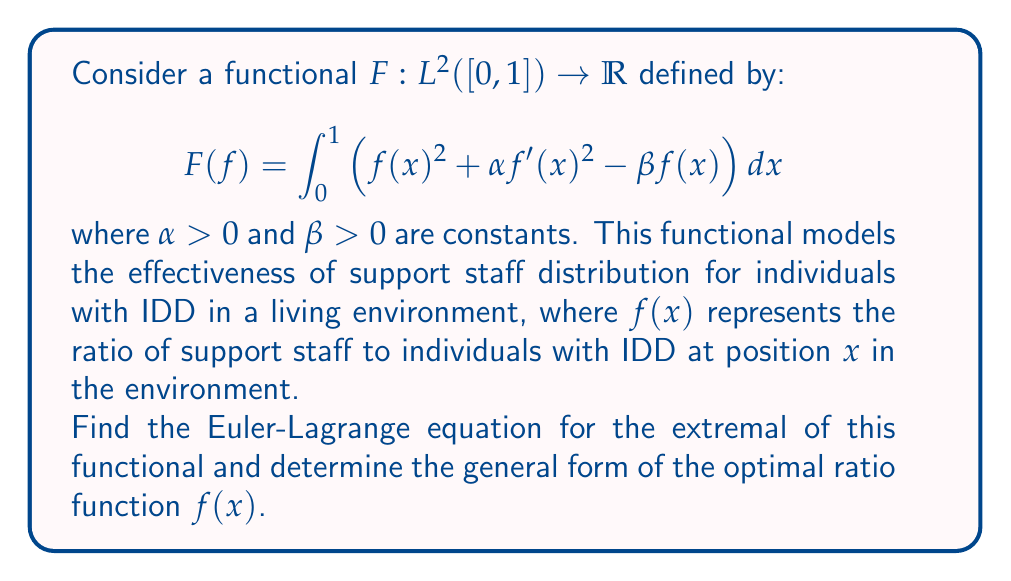Could you help me with this problem? To solve this problem, we'll use the Euler-Lagrange equation from the calculus of variations. The steps are as follows:

1) The Euler-Lagrange equation for a functional of the form $F(f) = \int_a^b L(x, f, f') dx$ is:

   $$\frac{\partial L}{\partial f} - \frac{d}{dx}\left(\frac{\partial L}{\partial f'}\right) = 0$$

2) In our case, $L(x, f, f') = f^2 + \alpha (f')^2 - \beta f$

3) Calculate the partial derivatives:
   
   $\frac{\partial L}{\partial f} = 2f - \beta$
   
   $\frac{\partial L}{\partial f'} = 2\alpha f'$

4) Substitute into the Euler-Lagrange equation:

   $$(2f - \beta) - \frac{d}{dx}(2\alpha f') = 0$$

5) Simplify:

   $$2f - \beta - 2\alpha f'' = 0$$

6) Rearrange to standard form:

   $$f'' - \frac{1}{\alpha}f = -\frac{\beta}{2\alpha}$$

7) This is a non-homogeneous second-order linear differential equation. The general solution is of the form:

   $$f(x) = c_1e^{\frac{x}{\sqrt{\alpha}}} + c_2e^{-\frac{x}{\sqrt{\alpha}}} + \frac{\beta}{2}$$

   where $c_1$ and $c_2$ are constants determined by boundary conditions.
Answer: The optimal ratio function $f(x)$ has the general form:

$$f(x) = c_1e^{\frac{x}{\sqrt{\alpha}}} + c_2e^{-\frac{x}{\sqrt{\alpha}}} + \frac{\beta}{2}$$

where $c_1$ and $c_2$ are constants determined by specific boundary conditions of the living environment. 